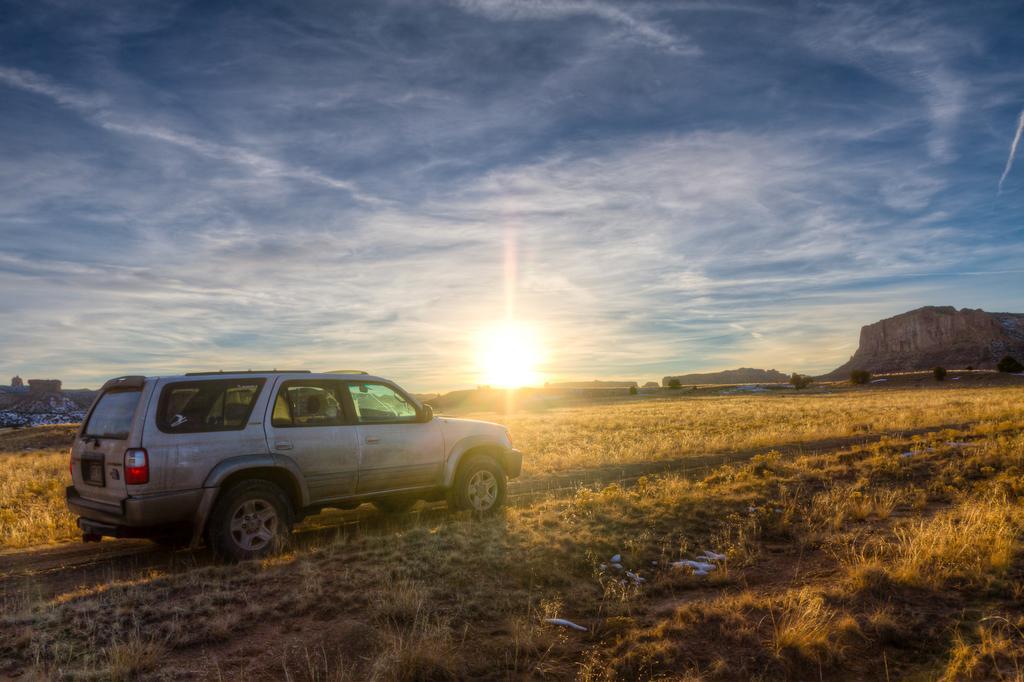Please provide a concise description of this image. In this image we can see there is a moving vehicle on the path, on the either sides of the path there are grass and a few other objects placed on the grass. In the background there are mountains and the sky. 